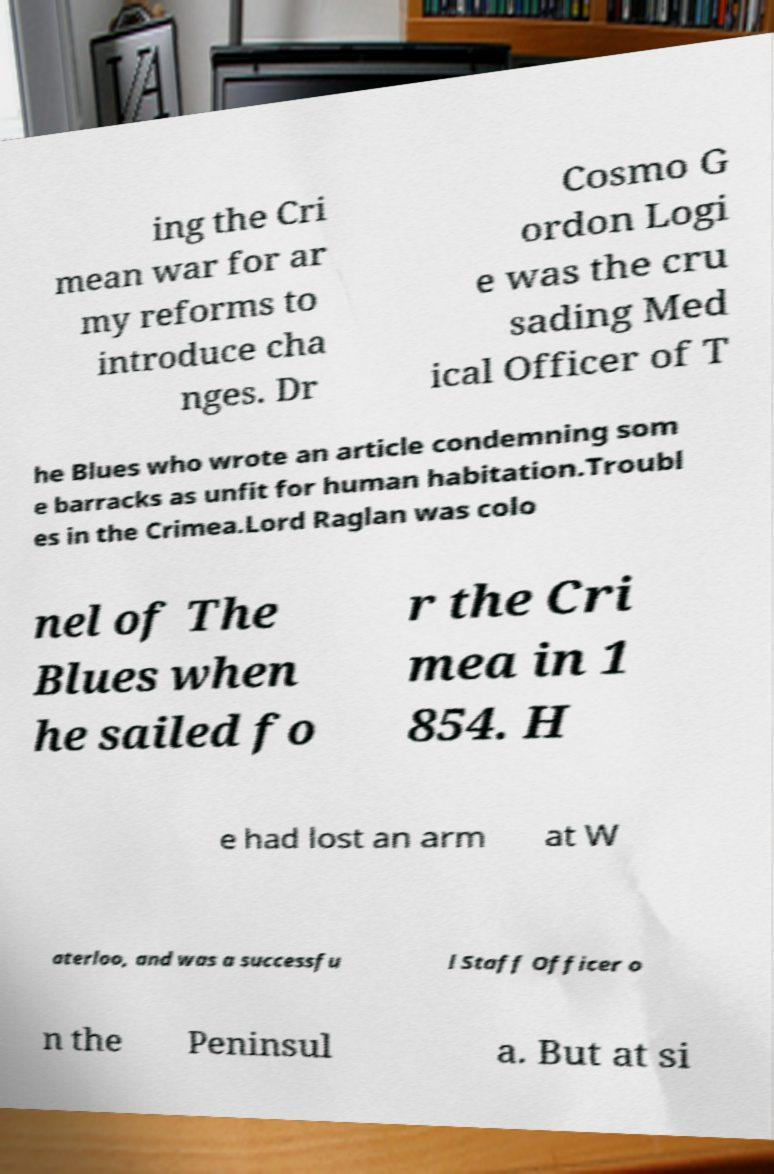Can you accurately transcribe the text from the provided image for me? ing the Cri mean war for ar my reforms to introduce cha nges. Dr Cosmo G ordon Logi e was the cru sading Med ical Officer of T he Blues who wrote an article condemning som e barracks as unfit for human habitation.Troubl es in the Crimea.Lord Raglan was colo nel of The Blues when he sailed fo r the Cri mea in 1 854. H e had lost an arm at W aterloo, and was a successfu l Staff Officer o n the Peninsul a. But at si 